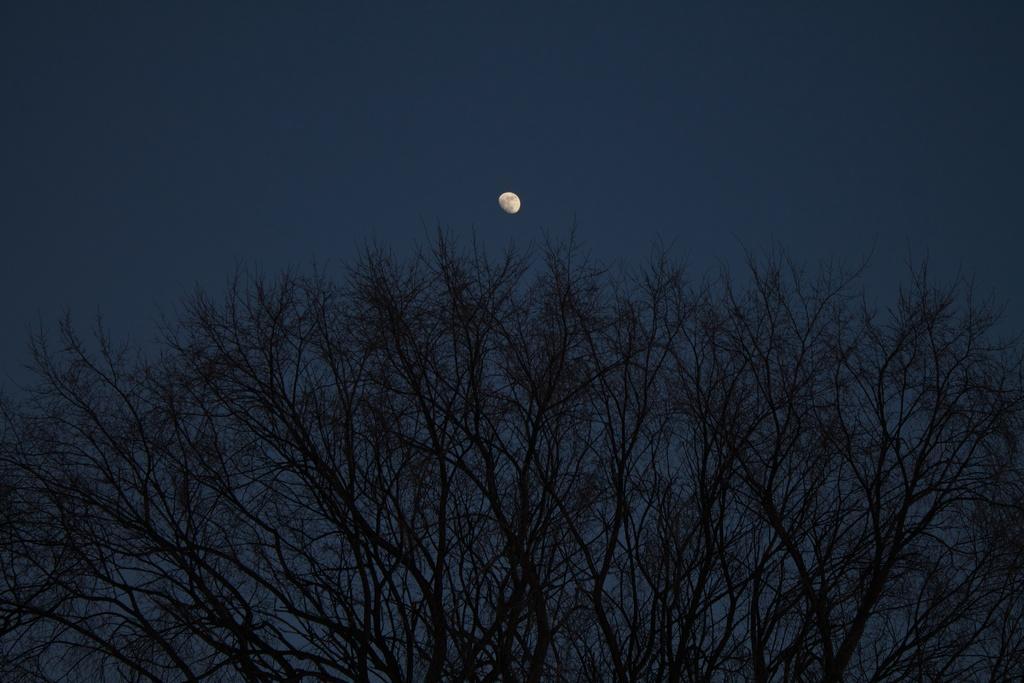How would you summarize this image in a sentence or two? There is a tree at the bottom of this image and there is a sky in the background. We can see the moon at the top of this image. 